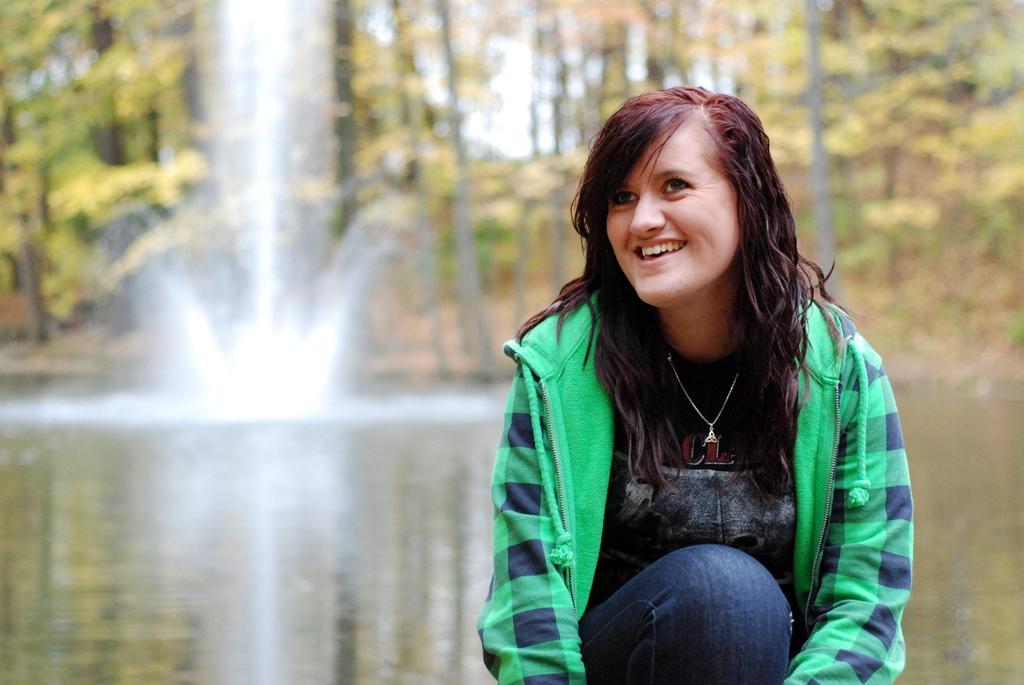Can you describe this image briefly? This image consists of a girl wearing green jacket. In the background, there is water along with trees and waterfall. She is in squatting position. 